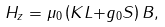<formula> <loc_0><loc_0><loc_500><loc_500>H _ { z } = \mu _ { 0 } \left ( K { L + } g _ { 0 } { S } \right ) { B } ,</formula> 